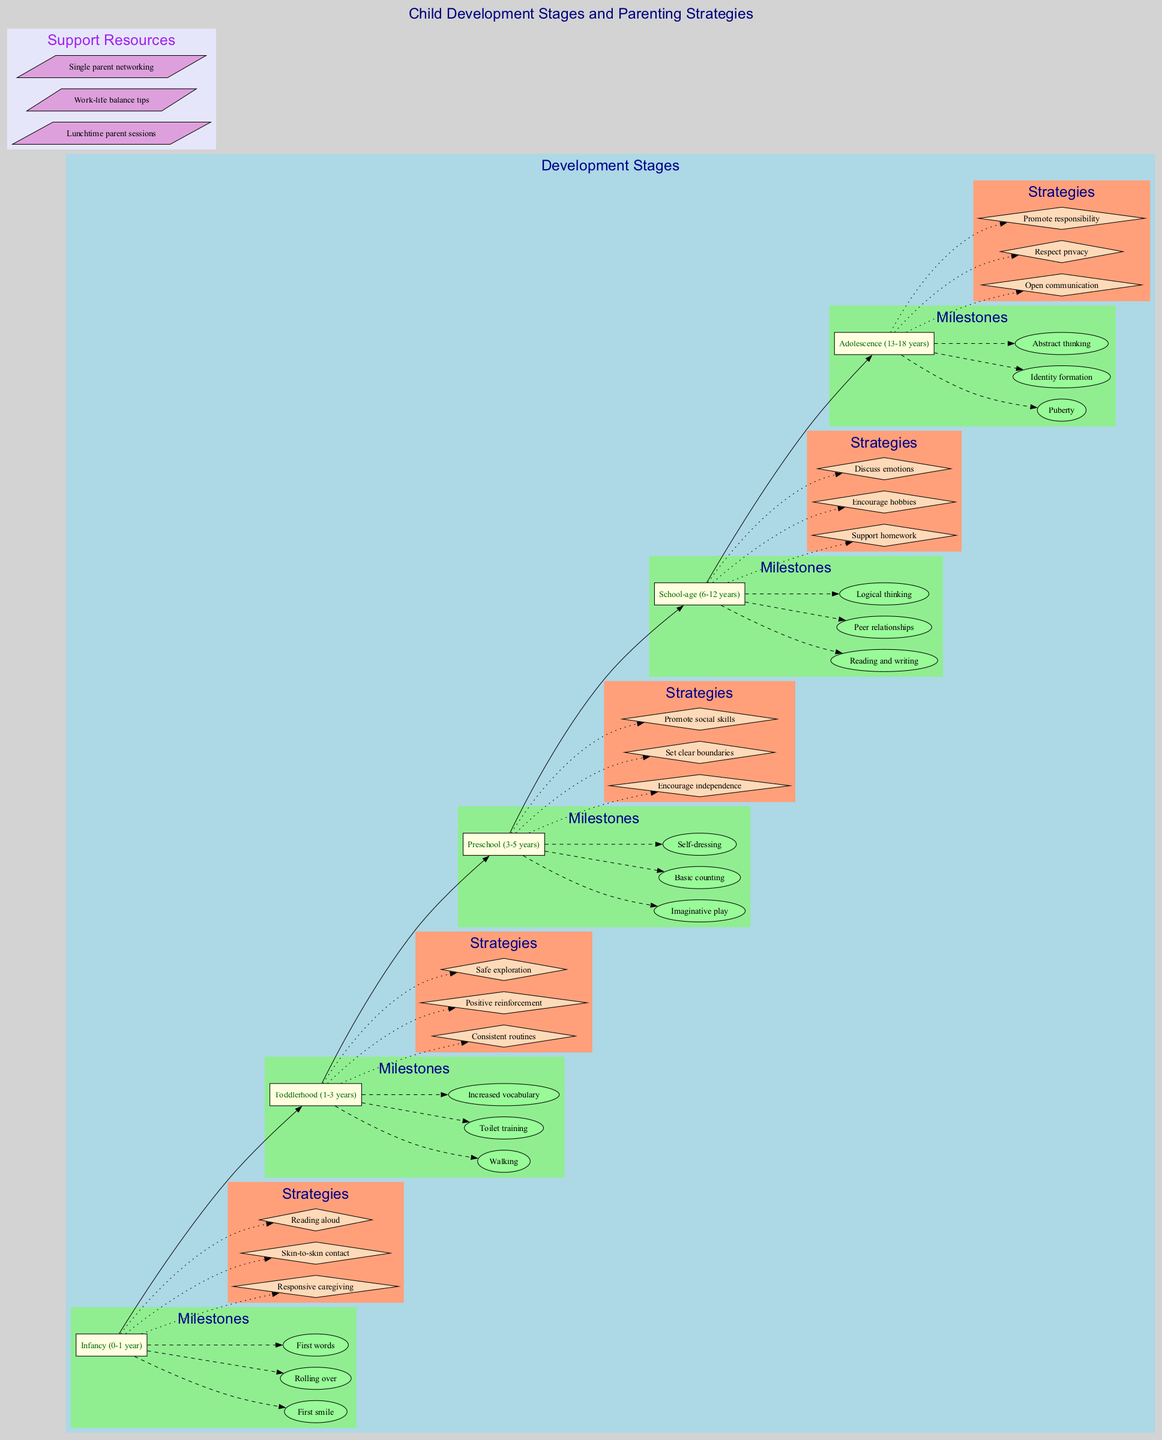What are the key milestones for toddlerhood? By examining the "Toddlerhood (1-3 years)" stage in the diagram, we identify the milestones listed directly under this stage: "Walking," "Toilet training," and "Increased vocabulary."
Answer: Walking, Toilet training, Increased vocabulary How many stages of child development are illustrated in the diagram? The diagram presents five distinct stages of child development, as indicated by the five boxes labeled from "Infancy" to "Adolescence."
Answer: 5 What parenting strategy is suggested for school-age children? Under the "School-age (6-12 years)" section of the diagram, the strategies listed include "Support homework," which serves as one suggestion for parenting during this stage.
Answer: Support homework Which stage features the milestone of puberty? The milestone of "Puberty" is located under the "Adolescence (13-18 years)" stage, as indicated by the milestone node connected to this stage's box.
Answer: Adolescence How many milestones are listed for preschoolers? The "Preschool (3-5 years)" stage in the diagram outlines three milestones, which include "Imaginative play," "Basic counting," and "Self-dressing."
Answer: 3 What is a parenting strategy for infancy? The strategies under the "Infancy (0-1 year)" stage include "Responsive caregiving," which is one example of the suggested approach for this stage.
Answer: Responsive caregiving Which support resource is focused on networking for single parents? Among the support resources listed in the diagram, "Single parent networking" explicitly addresses this need for social interaction and support for single parents.
Answer: Single parent networking What relationship connects the "Toddlerhood" stage to the milestone "Walking"? The diagram shows a dashed line edge from the "Toddlerhood" stage box to the ellipse labeled "Walking," indicating a milestone achieved during this developmental stage.
Answer: Dashed line Which parenting strategy emphasizes encouraging independence? The strategy of "Encourage independence" is specified under the "Preschool (3-5 years)" stage as a means to support child growth during this period.
Answer: Encourage independence 